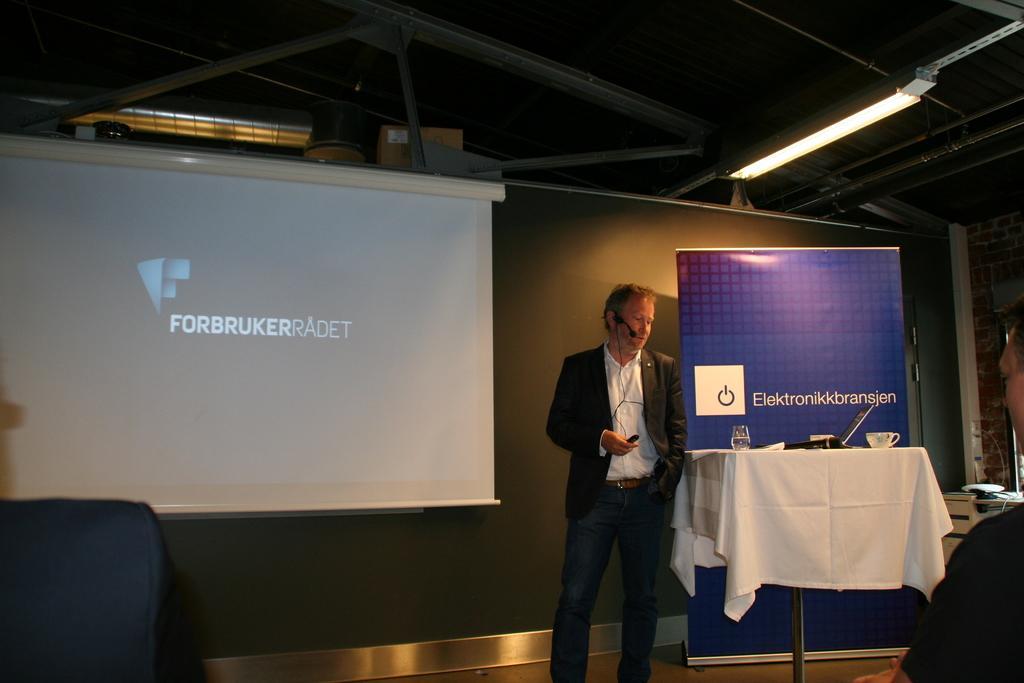Please provide a concise description of this image. This image consists of a man standing and wearing a suit. On the left, we can see a projector screen. At the top, there is a roof along with lights. On the right, there is a banner. And a table which is covered with a white cloth. On which there are cups and a glass kept. At the bottom, there is a floor. 